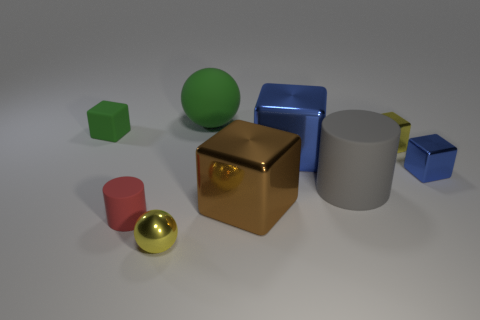The matte thing that is the same color as the small rubber cube is what size?
Offer a very short reply. Large. What number of rubber cubes are the same color as the matte ball?
Keep it short and to the point. 1. Do the big gray thing and the tiny rubber object on the right side of the tiny matte cube have the same shape?
Provide a short and direct response. Yes. What material is the large blue cube?
Give a very brief answer. Metal. There is a cylinder that is on the right side of the tiny yellow sphere in front of the green sphere that is behind the small blue block; what color is it?
Give a very brief answer. Gray. There is another thing that is the same shape as the big green thing; what material is it?
Provide a short and direct response. Metal. What number of blue shiny cubes are the same size as the green sphere?
Keep it short and to the point. 1. How many tiny yellow shiny things are there?
Ensure brevity in your answer.  2. Are the large green ball and the yellow thing to the right of the big gray matte cylinder made of the same material?
Your response must be concise. No. How many blue objects are large metal things or rubber cylinders?
Ensure brevity in your answer.  1. 